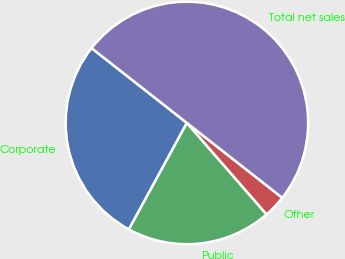<chart> <loc_0><loc_0><loc_500><loc_500><pie_chart><fcel>Corporate<fcel>Public<fcel>Other<fcel>Total net sales<nl><fcel>27.65%<fcel>19.35%<fcel>3.0%<fcel>50.0%<nl></chart> 